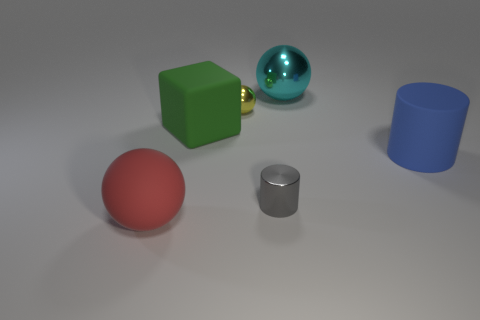There is a tiny metallic thing in front of the blue cylinder; does it have the same shape as the large red matte thing?
Provide a succinct answer. No. What size is the cylinder on the left side of the large sphere that is behind the big rubber thing left of the rubber cube?
Offer a very short reply. Small. What number of things are tiny cyan metallic objects or big blue rubber objects?
Your response must be concise. 1. What shape is the big thing that is both in front of the yellow ball and behind the big cylinder?
Keep it short and to the point. Cube. There is a large red rubber object; is its shape the same as the matte thing that is on the right side of the cyan shiny sphere?
Make the answer very short. No. There is a small yellow ball; are there any big blue rubber cylinders behind it?
Offer a very short reply. No. What number of cylinders are either big matte objects or gray things?
Your answer should be compact. 2. Does the yellow shiny thing have the same shape as the large red thing?
Provide a succinct answer. Yes. What size is the thing that is left of the big green thing?
Keep it short and to the point. Large. Are there any other metal cylinders of the same color as the tiny cylinder?
Make the answer very short. No. 